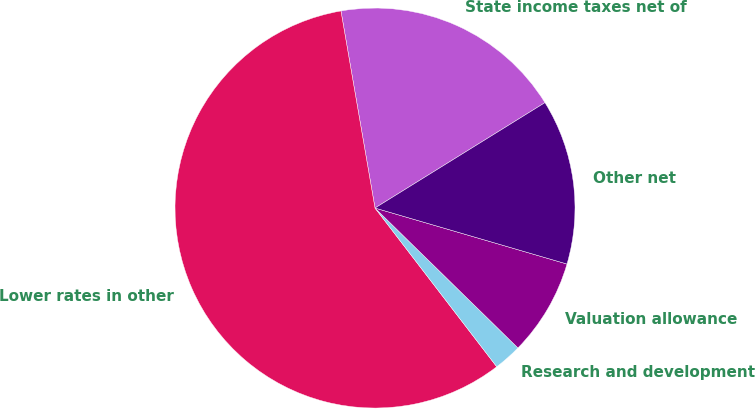Convert chart. <chart><loc_0><loc_0><loc_500><loc_500><pie_chart><fcel>State income taxes net of<fcel>Lower rates in other<fcel>Research and development<fcel>Valuation allowance<fcel>Other net<nl><fcel>18.89%<fcel>57.69%<fcel>2.26%<fcel>7.81%<fcel>13.35%<nl></chart> 